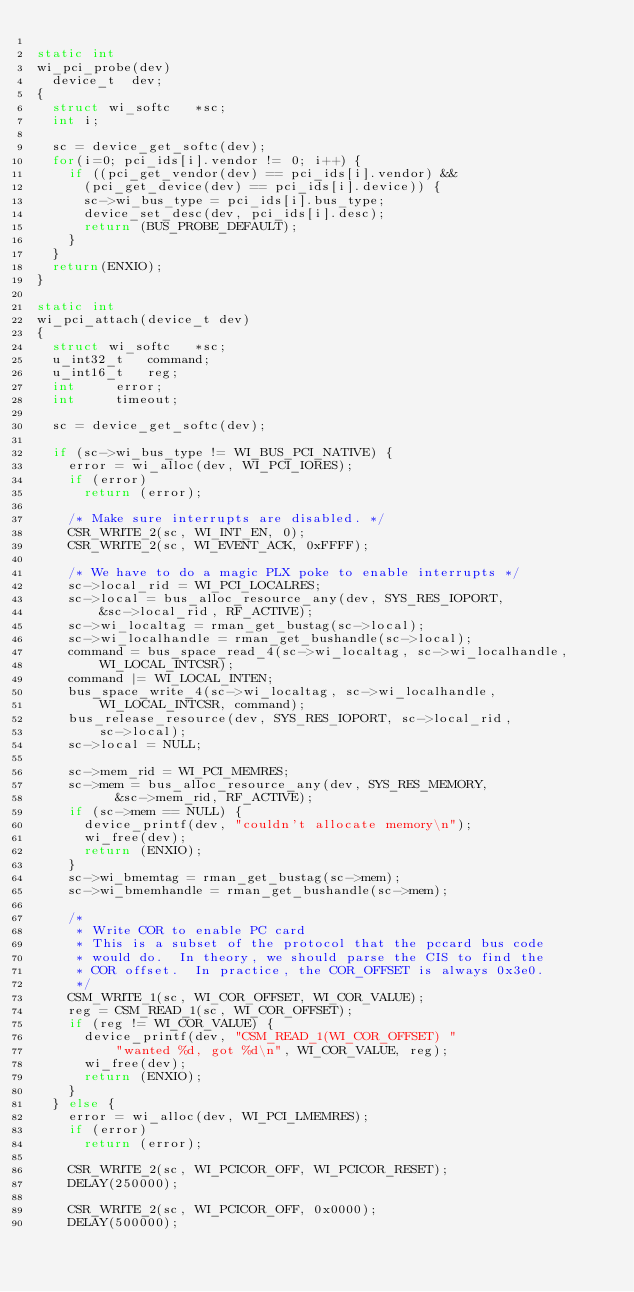Convert code to text. <code><loc_0><loc_0><loc_500><loc_500><_C_>
static int
wi_pci_probe(dev)
	device_t	dev;
{
	struct wi_softc		*sc;
	int i;

	sc = device_get_softc(dev);
	for(i=0; pci_ids[i].vendor != 0; i++) {
		if ((pci_get_vendor(dev) == pci_ids[i].vendor) &&
			(pci_get_device(dev) == pci_ids[i].device)) {
			sc->wi_bus_type = pci_ids[i].bus_type;
			device_set_desc(dev, pci_ids[i].desc);
			return (BUS_PROBE_DEFAULT);
		}
	}
	return(ENXIO);
}

static int
wi_pci_attach(device_t dev)
{
	struct wi_softc		*sc;
	u_int32_t		command;
	u_int16_t		reg;
	int			error;
	int			timeout;

	sc = device_get_softc(dev);

	if (sc->wi_bus_type != WI_BUS_PCI_NATIVE) {
		error = wi_alloc(dev, WI_PCI_IORES);
		if (error)
			return (error);

		/* Make sure interrupts are disabled. */
		CSR_WRITE_2(sc, WI_INT_EN, 0);
		CSR_WRITE_2(sc, WI_EVENT_ACK, 0xFFFF);

		/* We have to do a magic PLX poke to enable interrupts */
		sc->local_rid = WI_PCI_LOCALRES;
		sc->local = bus_alloc_resource_any(dev, SYS_RES_IOPORT,
		    &sc->local_rid, RF_ACTIVE);
		sc->wi_localtag = rman_get_bustag(sc->local);
		sc->wi_localhandle = rman_get_bushandle(sc->local);
		command = bus_space_read_4(sc->wi_localtag, sc->wi_localhandle,
		    WI_LOCAL_INTCSR);
		command |= WI_LOCAL_INTEN;
		bus_space_write_4(sc->wi_localtag, sc->wi_localhandle,
		    WI_LOCAL_INTCSR, command);
		bus_release_resource(dev, SYS_RES_IOPORT, sc->local_rid,
		    sc->local);
		sc->local = NULL;

		sc->mem_rid = WI_PCI_MEMRES;
		sc->mem = bus_alloc_resource_any(dev, SYS_RES_MEMORY,
					&sc->mem_rid, RF_ACTIVE);
		if (sc->mem == NULL) {
			device_printf(dev, "couldn't allocate memory\n");
			wi_free(dev);
			return (ENXIO);
		}
		sc->wi_bmemtag = rman_get_bustag(sc->mem);
		sc->wi_bmemhandle = rman_get_bushandle(sc->mem);

		/*
		 * Write COR to enable PC card
		 * This is a subset of the protocol that the pccard bus code
		 * would do.  In theory, we should parse the CIS to find the
		 * COR offset.  In practice, the COR_OFFSET is always 0x3e0.
		 */
		CSM_WRITE_1(sc, WI_COR_OFFSET, WI_COR_VALUE); 
		reg = CSM_READ_1(sc, WI_COR_OFFSET);
		if (reg != WI_COR_VALUE) {
			device_printf(dev, "CSM_READ_1(WI_COR_OFFSET) "
			    "wanted %d, got %d\n", WI_COR_VALUE, reg);
			wi_free(dev);
			return (ENXIO);
		}
	} else {
		error = wi_alloc(dev, WI_PCI_LMEMRES);
		if (error)
			return (error);

		CSR_WRITE_2(sc, WI_PCICOR_OFF, WI_PCICOR_RESET);
		DELAY(250000);

		CSR_WRITE_2(sc, WI_PCICOR_OFF, 0x0000);
		DELAY(500000);
</code> 